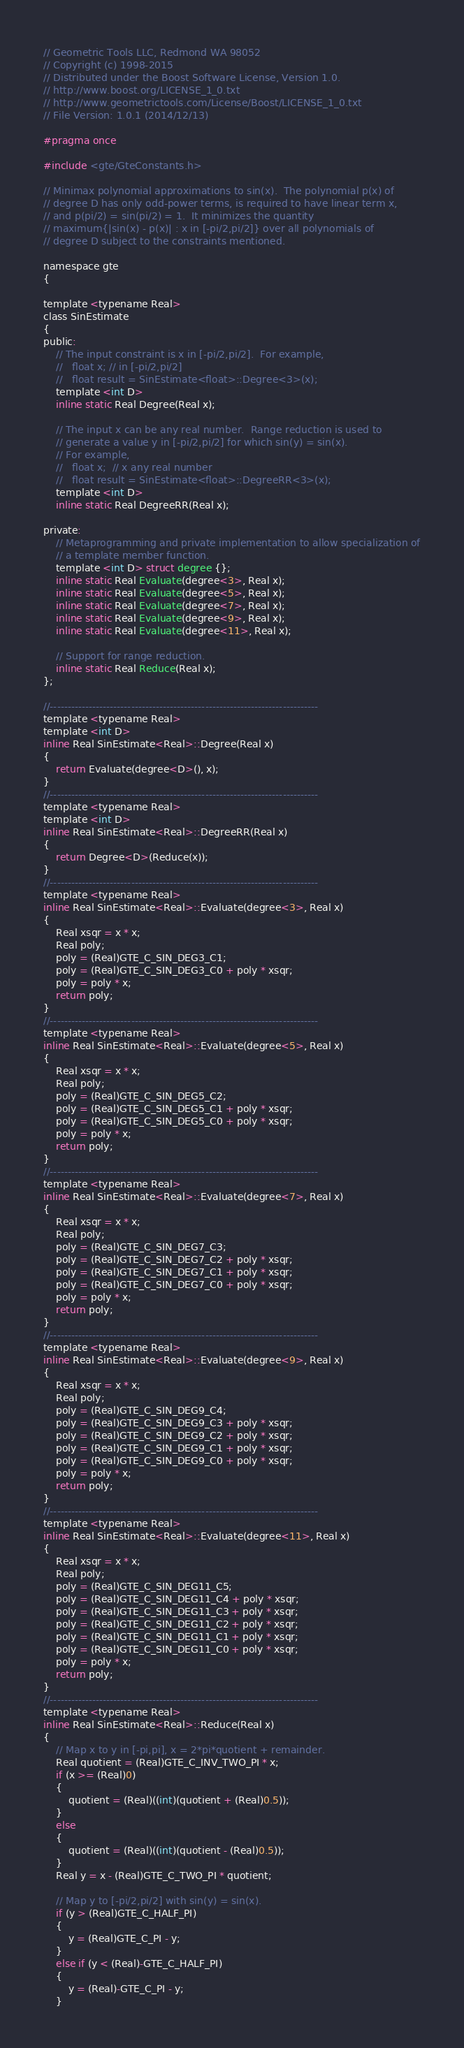Convert code to text. <code><loc_0><loc_0><loc_500><loc_500><_C_>// Geometric Tools LLC, Redmond WA 98052
// Copyright (c) 1998-2015
// Distributed under the Boost Software License, Version 1.0.
// http://www.boost.org/LICENSE_1_0.txt
// http://www.geometrictools.com/License/Boost/LICENSE_1_0.txt
// File Version: 1.0.1 (2014/12/13)

#pragma once

#include <gte/GteConstants.h>

// Minimax polynomial approximations to sin(x).  The polynomial p(x) of
// degree D has only odd-power terms, is required to have linear term x,
// and p(pi/2) = sin(pi/2) = 1.  It minimizes the quantity
// maximum{|sin(x) - p(x)| : x in [-pi/2,pi/2]} over all polynomials of
// degree D subject to the constraints mentioned.

namespace gte
{

template <typename Real>
class SinEstimate
{
public:
    // The input constraint is x in [-pi/2,pi/2].  For example,
    //   float x; // in [-pi/2,pi/2]
    //   float result = SinEstimate<float>::Degree<3>(x);
    template <int D>
    inline static Real Degree(Real x);

    // The input x can be any real number.  Range reduction is used to
    // generate a value y in [-pi/2,pi/2] for which sin(y) = sin(x).
    // For example,
    //   float x;  // x any real number
    //   float result = SinEstimate<float>::DegreeRR<3>(x);
    template <int D>
    inline static Real DegreeRR(Real x);

private:
    // Metaprogramming and private implementation to allow specialization of
    // a template member function.
    template <int D> struct degree {};
    inline static Real Evaluate(degree<3>, Real x);
    inline static Real Evaluate(degree<5>, Real x);
    inline static Real Evaluate(degree<7>, Real x);
    inline static Real Evaluate(degree<9>, Real x);
    inline static Real Evaluate(degree<11>, Real x);

    // Support for range reduction.
    inline static Real Reduce(Real x);
};

//----------------------------------------------------------------------------
template <typename Real>
template <int D>
inline Real SinEstimate<Real>::Degree(Real x)
{
    return Evaluate(degree<D>(), x);
}
//----------------------------------------------------------------------------
template <typename Real>
template <int D>
inline Real SinEstimate<Real>::DegreeRR(Real x)
{
    return Degree<D>(Reduce(x));
}
//----------------------------------------------------------------------------
template <typename Real>
inline Real SinEstimate<Real>::Evaluate(degree<3>, Real x)
{
    Real xsqr = x * x;
    Real poly;
    poly = (Real)GTE_C_SIN_DEG3_C1;
    poly = (Real)GTE_C_SIN_DEG3_C0 + poly * xsqr;
    poly = poly * x;
    return poly;
}
//----------------------------------------------------------------------------
template <typename Real>
inline Real SinEstimate<Real>::Evaluate(degree<5>, Real x)
{
    Real xsqr = x * x;
    Real poly;
    poly = (Real)GTE_C_SIN_DEG5_C2;
    poly = (Real)GTE_C_SIN_DEG5_C1 + poly * xsqr;
    poly = (Real)GTE_C_SIN_DEG5_C0 + poly * xsqr;
    poly = poly * x;
    return poly;
}
//----------------------------------------------------------------------------
template <typename Real>
inline Real SinEstimate<Real>::Evaluate(degree<7>, Real x)
{
    Real xsqr = x * x;
    Real poly;
    poly = (Real)GTE_C_SIN_DEG7_C3;
    poly = (Real)GTE_C_SIN_DEG7_C2 + poly * xsqr;
    poly = (Real)GTE_C_SIN_DEG7_C1 + poly * xsqr;
    poly = (Real)GTE_C_SIN_DEG7_C0 + poly * xsqr;
    poly = poly * x;
    return poly;
}
//----------------------------------------------------------------------------
template <typename Real>
inline Real SinEstimate<Real>::Evaluate(degree<9>, Real x)
{
    Real xsqr = x * x;
    Real poly;
    poly = (Real)GTE_C_SIN_DEG9_C4;
    poly = (Real)GTE_C_SIN_DEG9_C3 + poly * xsqr;
    poly = (Real)GTE_C_SIN_DEG9_C2 + poly * xsqr;
    poly = (Real)GTE_C_SIN_DEG9_C1 + poly * xsqr;
    poly = (Real)GTE_C_SIN_DEG9_C0 + poly * xsqr;
    poly = poly * x;
    return poly;
}
//----------------------------------------------------------------------------
template <typename Real>
inline Real SinEstimate<Real>::Evaluate(degree<11>, Real x)
{
    Real xsqr = x * x;
    Real poly;
    poly = (Real)GTE_C_SIN_DEG11_C5;
    poly = (Real)GTE_C_SIN_DEG11_C4 + poly * xsqr;
    poly = (Real)GTE_C_SIN_DEG11_C3 + poly * xsqr;
    poly = (Real)GTE_C_SIN_DEG11_C2 + poly * xsqr;
    poly = (Real)GTE_C_SIN_DEG11_C1 + poly * xsqr;
    poly = (Real)GTE_C_SIN_DEG11_C0 + poly * xsqr;
    poly = poly * x;
    return poly;
}
//----------------------------------------------------------------------------
template <typename Real>
inline Real SinEstimate<Real>::Reduce(Real x)
{
    // Map x to y in [-pi,pi], x = 2*pi*quotient + remainder.
    Real quotient = (Real)GTE_C_INV_TWO_PI * x;
    if (x >= (Real)0)
    {
        quotient = (Real)((int)(quotient + (Real)0.5));
    }
    else
    {
        quotient = (Real)((int)(quotient - (Real)0.5));
    }
    Real y = x - (Real)GTE_C_TWO_PI * quotient;

    // Map y to [-pi/2,pi/2] with sin(y) = sin(x).
    if (y > (Real)GTE_C_HALF_PI)
    {
        y = (Real)GTE_C_PI - y;
    }
    else if (y < (Real)-GTE_C_HALF_PI)
    {
        y = (Real)-GTE_C_PI - y;
    }</code> 